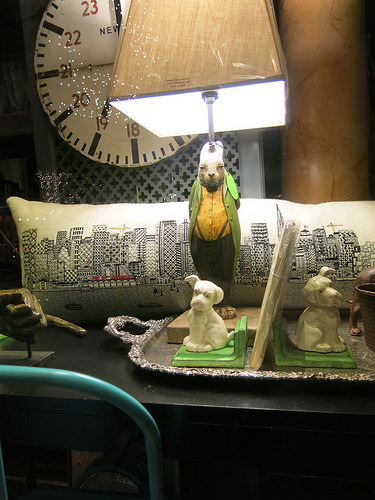<image>
Is there a rabbit on the dog? No. The rabbit is not positioned on the dog. They may be near each other, but the rabbit is not supported by or resting on top of the dog. 